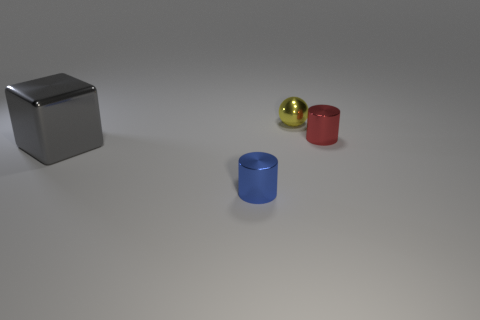Add 4 large brown rubber objects. How many objects exist? 8 Subtract all blocks. How many objects are left? 3 Subtract 0 green balls. How many objects are left? 4 Subtract all large cubes. Subtract all brown cylinders. How many objects are left? 3 Add 4 gray metallic things. How many gray metallic things are left? 5 Add 2 big cyan rubber objects. How many big cyan rubber objects exist? 2 